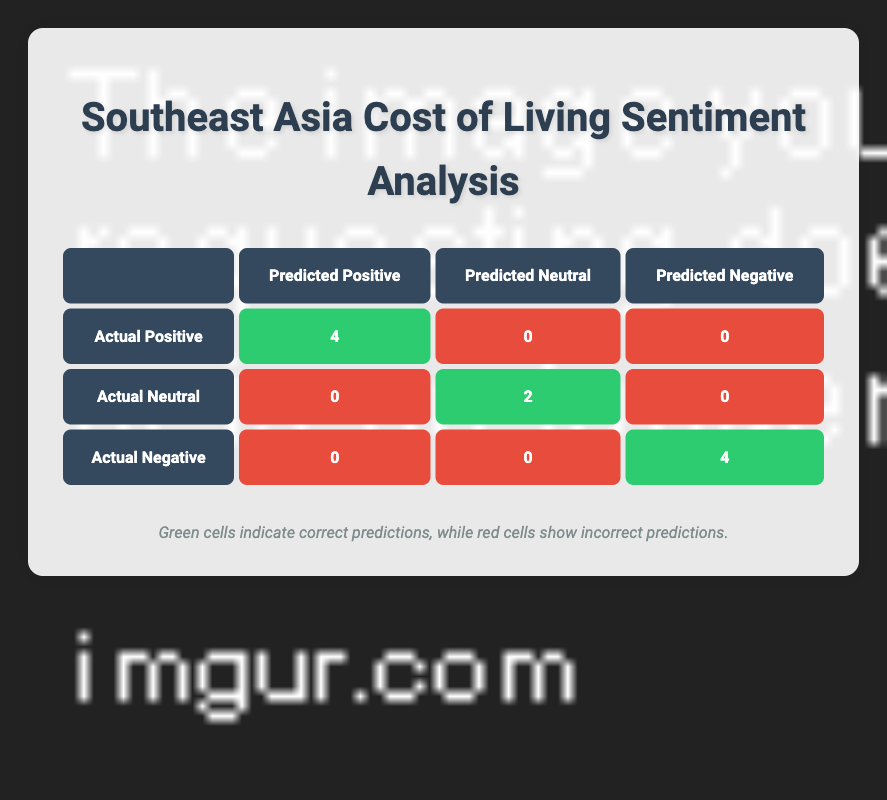What is the total number of posts classified as positive? In the table, under the "Actual Positive" row, there are 4 entries classified as correct predictions for positive sentiment. Therefore, the total number of posts classified as positive is 4.
Answer: 4 How many posts were accurately predicted as neutral? In the table, under the "Actual Neutral" row, there are 2 entries classified as correct predictions for neutral sentiment. So, the number of posts accurately predicted as neutral is 2.
Answer: 2 What is the count of posts that were incorrectly classified as positive? In the "Actual Neutral" and "Actual Negative" rows, there are no entries under "Predicted Positive" classified as incorrectly predicted. Therefore, the count of posts incorrectly classified as positive is 0.
Answer: 0 Is there any post that was incorrectly predicted as neutral? The table shows no posts under "Actual Positive" or "Actual Negative" classified as predicted neutral. Therefore, there are no incorrect predictions for neutrals.
Answer: No How many total posts were analyzed for sentiment? The total number of posts represented in the data set is 10 (1 for each post from the provided data).
Answer: 10 What is the proportion of correct predictions to total posts analyzed? To find this, add up all the correct predictions: 4 (positive) + 2 (neutral) + 4 (negative) = 10. Since the total is also 10, the proportion is 10/10, which equals 1 or 100%.
Answer: 100% How many posts were classified as negative sentiments? The "Actual Negative" row shows that there are 4 correct predictions for negative sentiment. Thus, the total number of posts classified as negative sentiments is 4.
Answer: 4 If we consider only the incorrectly predicted posts, what are they? In this case, there are no incorrectly predicted posts since all neutral and positive classifications are correct. Therefore, the incorrectly predicted posts are none.
Answer: None What is the difference between the number of positive and negative sentiments correctly predicted? The number of correctly predicted positive sentiments is 4, while the number of correctly predicted negative sentiments is 4 as well. The difference is 4 - 4 = 0.
Answer: 0 What does the table indicate about the model's performance regarding sentiment analysis? The table indicates that the model predicts sentiments accurately, as most (8 out of 10) predictions are correct, demonstrating reliable performance in classifying sentiments.
Answer: Reliable performance 